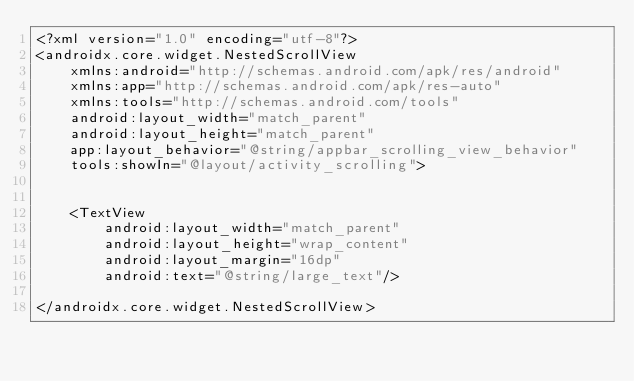<code> <loc_0><loc_0><loc_500><loc_500><_XML_><?xml version="1.0" encoding="utf-8"?>
<androidx.core.widget.NestedScrollView
    xmlns:android="http://schemas.android.com/apk/res/android"
    xmlns:app="http://schemas.android.com/apk/res-auto"
    xmlns:tools="http://schemas.android.com/tools"
    android:layout_width="match_parent"
    android:layout_height="match_parent"
    app:layout_behavior="@string/appbar_scrolling_view_behavior"
    tools:showIn="@layout/activity_scrolling">


    <TextView
        android:layout_width="match_parent"
        android:layout_height="wrap_content"
        android:layout_margin="16dp"
        android:text="@string/large_text"/>

</androidx.core.widget.NestedScrollView></code> 